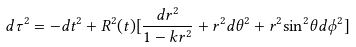<formula> <loc_0><loc_0><loc_500><loc_500>d \tau ^ { 2 } = - d t ^ { 2 } + { R ^ { 2 } } ( t ) [ \frac { d r ^ { 2 } } { 1 - k r ^ { 2 } } + { r ^ { 2 } } d \theta ^ { 2 } + { r ^ { 2 } } { \sin ^ { 2 } } { \theta } d \phi ^ { 2 } ]</formula> 